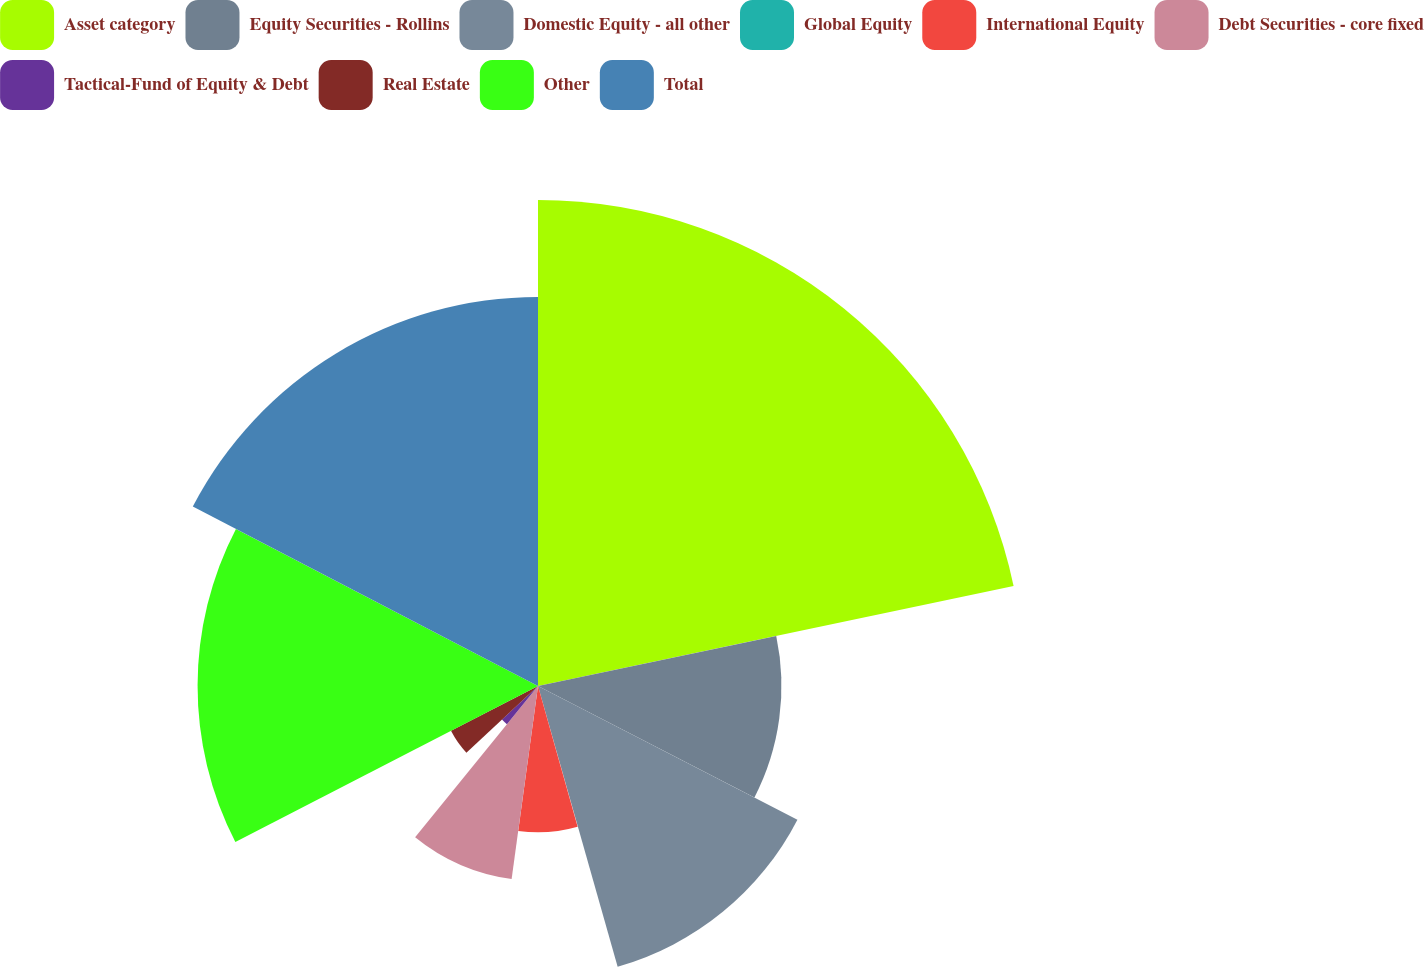Convert chart to OTSL. <chart><loc_0><loc_0><loc_500><loc_500><pie_chart><fcel>Asset category<fcel>Equity Securities - Rollins<fcel>Domestic Equity - all other<fcel>Global Equity<fcel>International Equity<fcel>Debt Securities - core fixed<fcel>Tactical-Fund of Equity & Debt<fcel>Real Estate<fcel>Other<fcel>Total<nl><fcel>21.7%<fcel>10.87%<fcel>13.03%<fcel>0.03%<fcel>6.53%<fcel>8.7%<fcel>2.2%<fcel>4.37%<fcel>15.2%<fcel>17.37%<nl></chart> 